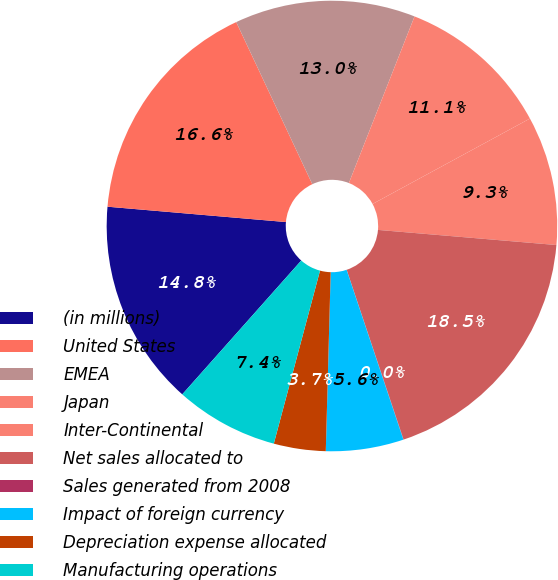<chart> <loc_0><loc_0><loc_500><loc_500><pie_chart><fcel>(in millions)<fcel>United States<fcel>EMEA<fcel>Japan<fcel>Inter-Continental<fcel>Net sales allocated to<fcel>Sales generated from 2008<fcel>Impact of foreign currency<fcel>Depreciation expense allocated<fcel>Manufacturing operations<nl><fcel>14.8%<fcel>16.65%<fcel>12.96%<fcel>11.11%<fcel>9.26%<fcel>18.5%<fcel>0.02%<fcel>5.57%<fcel>3.72%<fcel>7.41%<nl></chart> 